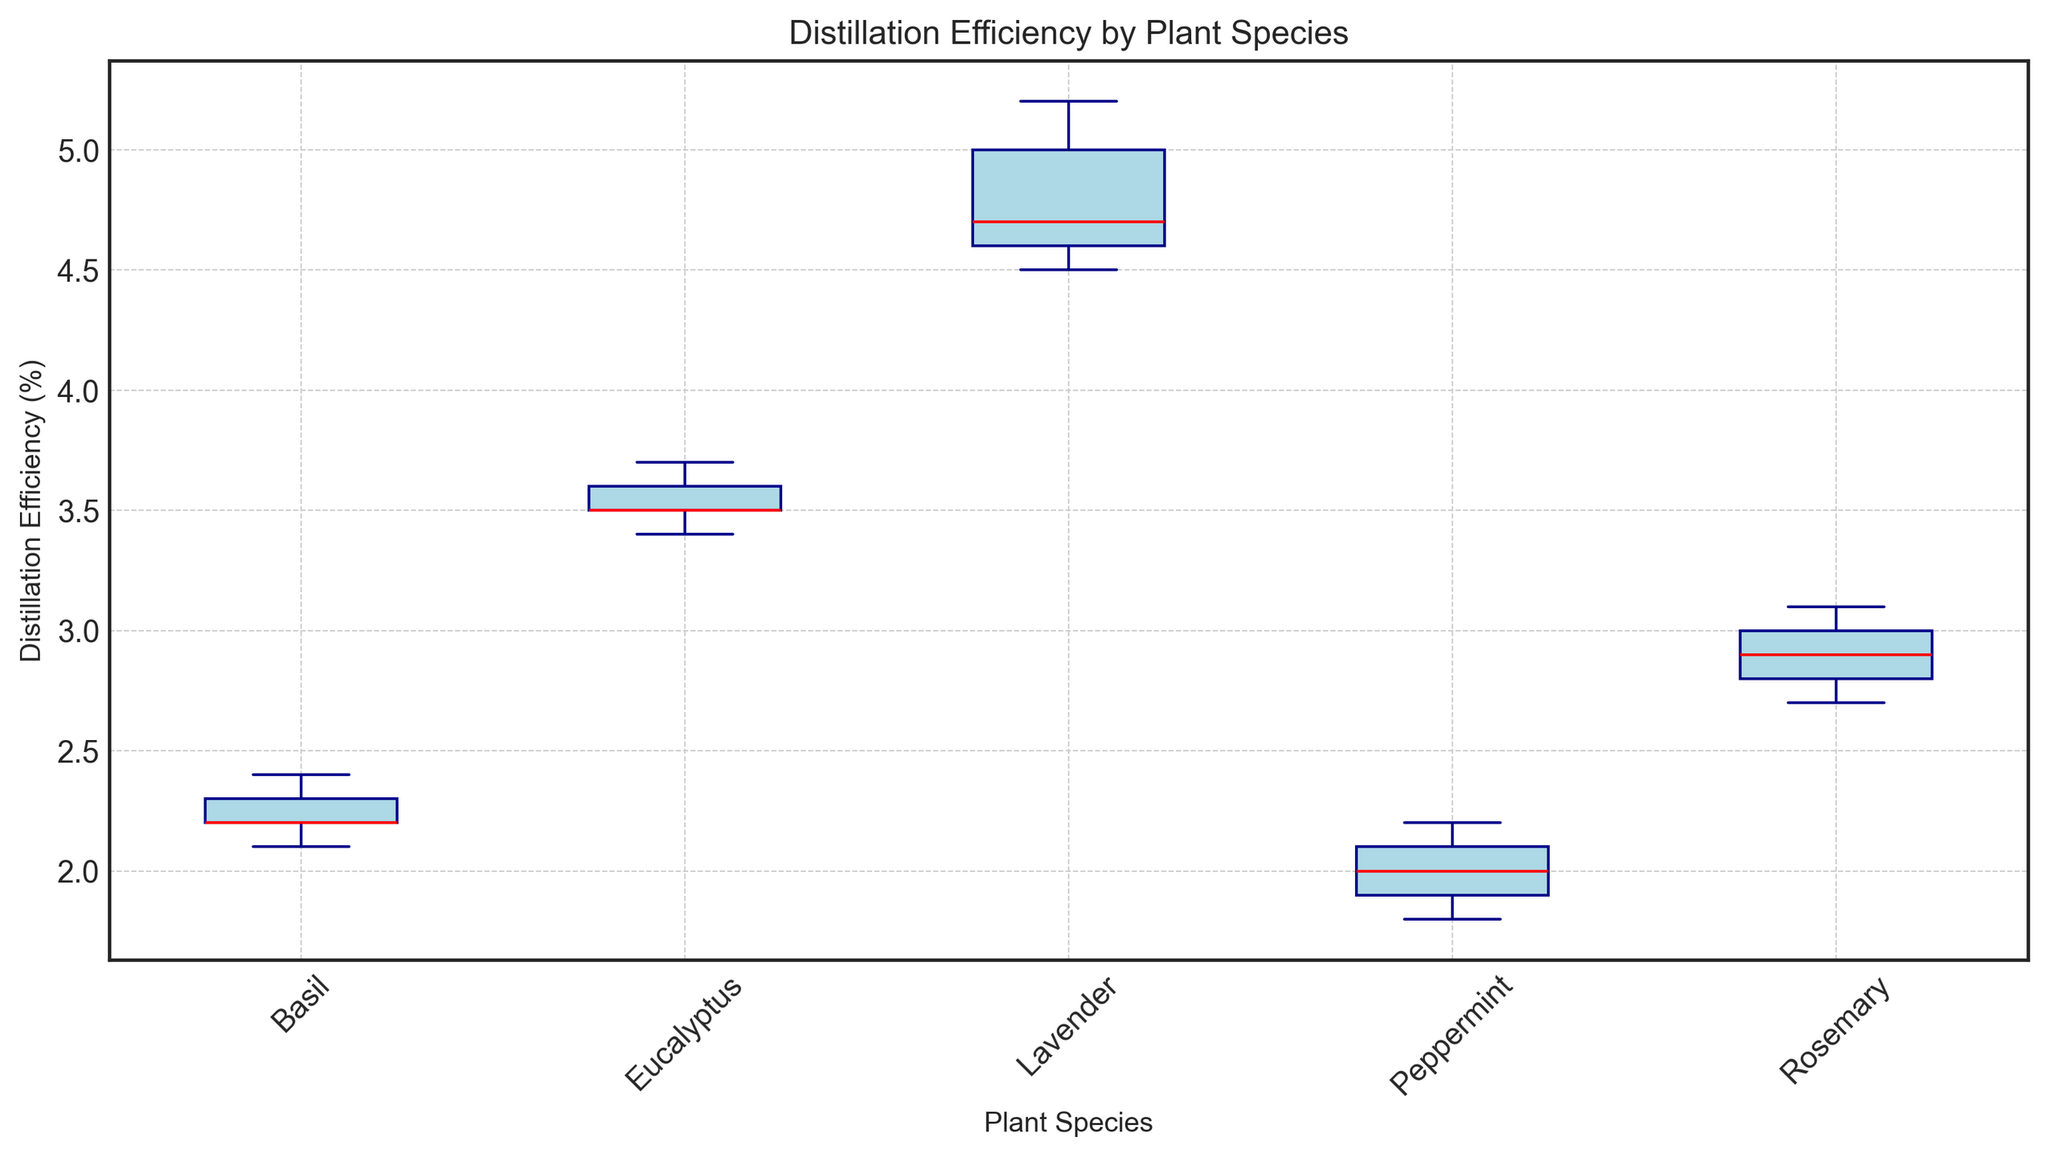What is the median distillation efficiency (%) for Lavender? To find the median distillation efficiency for Lavender, locate the central value of the sorted data points for Lavender (4.5, 4.6, 4.7, 5.0, 5.2). The median is the middle value, which is 4.7.
Answer: 4.7 Which plant species has the highest median distillation efficiency (%)? Identify the median values for each plant species by looking at the middle line within each box in the plot. Lavender has the highest median since its median line is higher than the others.
Answer: Lavender How does the median distillation efficiency (%) for Eucalyptus compare to that of Rosemary? Compare the median lines within the boxes for Eucalyptus and Rosemary. Eucalyptus has a higher median (around 3.5) compared to Rosemary (around 2.9).
Answer: Eucalyptus is higher Which plant species shows the least variability in distillation efficiency (%)? Variability is indicated by the height of the box. The box for Eucalyptus is the shortest, indicating the least variability.
Answer: Eucalyptus What is the range of distillation efficiency (%) for Peppermint? The range is calculated by subtracting the minimum value from the maximum value within the whiskers for Peppermint. The values are 1.8 (minimum) and 2.2 (maximum), so the range is 2.2 - 1.8 = 0.4.
Answer: 0.4 Which plant species has the widest interquartile range (IQR) for distillation efficiency (%)? The IQR is represented by the height of the box. The box with the greatest height is for Lavender, indicating the widest IQR.
Answer: Lavender What is the difference between the median distillation efficiencies (%) of Lavender and Basil? Subtract the median efficiency of Basil from the median of Lavender. The median for Lavender is 4.7, and for Basil, it is approximately 2.2; so the difference is 4.7 - 2.2 = 2.5.
Answer: 2.5 Which plant species shows the largest outlier, and what is its value? An outlier is a data point outside the whiskers. No outliers are shown in the figure, so there is no largest outlier.
Answer: None 